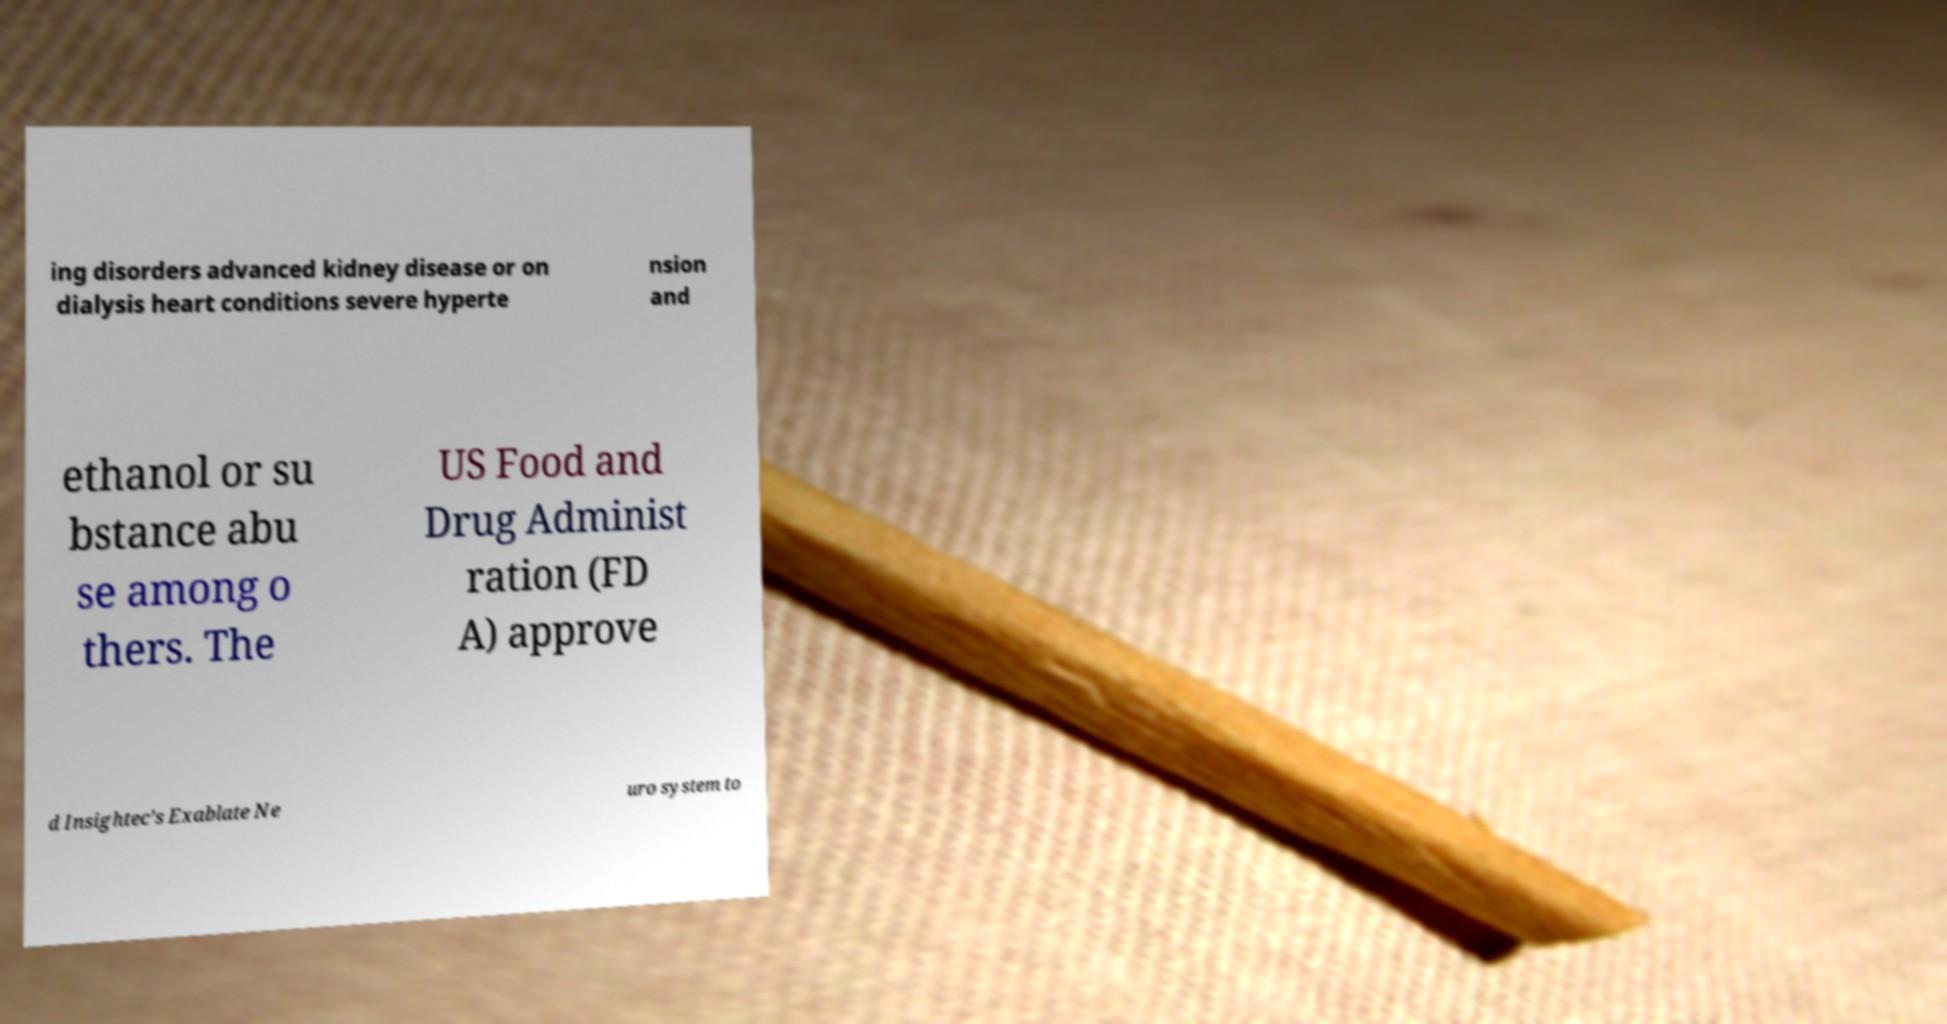I need the written content from this picture converted into text. Can you do that? ing disorders advanced kidney disease or on dialysis heart conditions severe hyperte nsion and ethanol or su bstance abu se among o thers. The US Food and Drug Administ ration (FD A) approve d Insightec’s Exablate Ne uro system to 